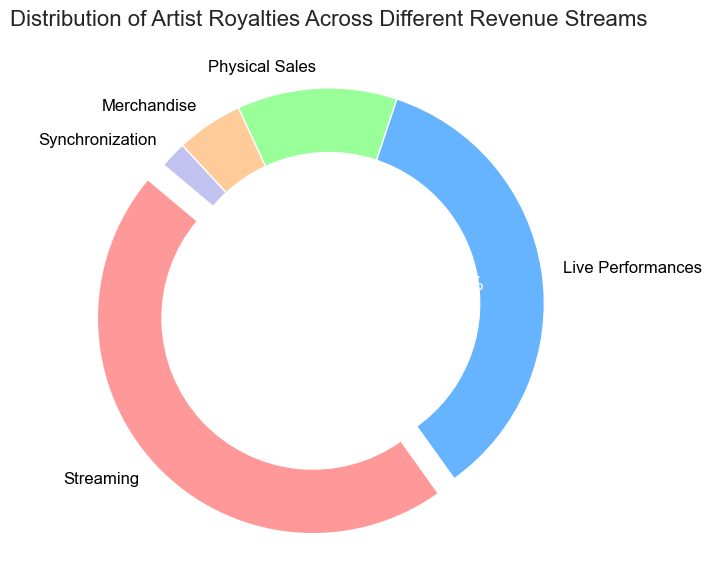Which revenue stream has the highest percentage? By looking at the chart, the largest portion of the pie chart corresponds to Streaming, which has been visually made more prominent by being exploded out. This indicates it has the highest percentage.
Answer: Streaming Which two revenue streams together constitute more than 80% of the total royalties? To determine this, add the percentages of the top two revenue streams: Streaming (46%) + Live Performances (35%) = 81%, which is more than 80%.
Answer: Streaming and Live Performances Is the percentage of Physical Sales greater than, less than, or equal to the combined percentage of Merchandise and Synchronization? We need to compare Physical Sales (12%) with the combined percentage of Merchandise (5%) and Synchronization (2%), which is 5% + 2% = 7%. Clearly, 12% is greater than 7%.
Answer: Greater than What is the percentage difference between the Streaming and Live Performances revenue streams? Calculate the difference by subtracting the percentage of Live Performances from Streaming, i.e., 46% - 35% = 11%.
Answer: 11% Which revenue stream constitutes the smallest percentage? The smallest slice of the pie chart is assigned to Synchronization, making it visually clear that it has the smallest percentage.
Answer: Synchronization If the total royalties are $100,000, how much do the Live Performances contribute? Calculate the contribution by taking 35% of $100,000. Thus, Live Performances contribute 0.35 * 100,000 = $35,000.
Answer: $35,000 How does the percentage of Live Performances compare to that of Physical Sales? By comparing directly from the pie chart, Live Performances have a percentage of 35%, while Physical Sales have 12%. Clearly, Live Performances are significantly higher.
Answer: Higher What is the total percentage contributed by the three smallest revenue streams? Summing up the smallest percentages: Physical Sales (12%) + Merchandise (5%) + Synchronization (2%) = 19%.
Answer: 19% Which portion is not exploded in the pie chart but still has a significant impact on the total percentage? Live Performances have a significant percentage (35%) and is not exploded in the chart, unlike Streaming.
Answer: Live Performances If there were no Merchandise and Synchronization royalties, what percentage would the other three streams represent together? Calculate the new total for Streaming, Live Performances, and Physical Sales, which is 46% + 35% + 12% = 93%.
Answer: 93% 